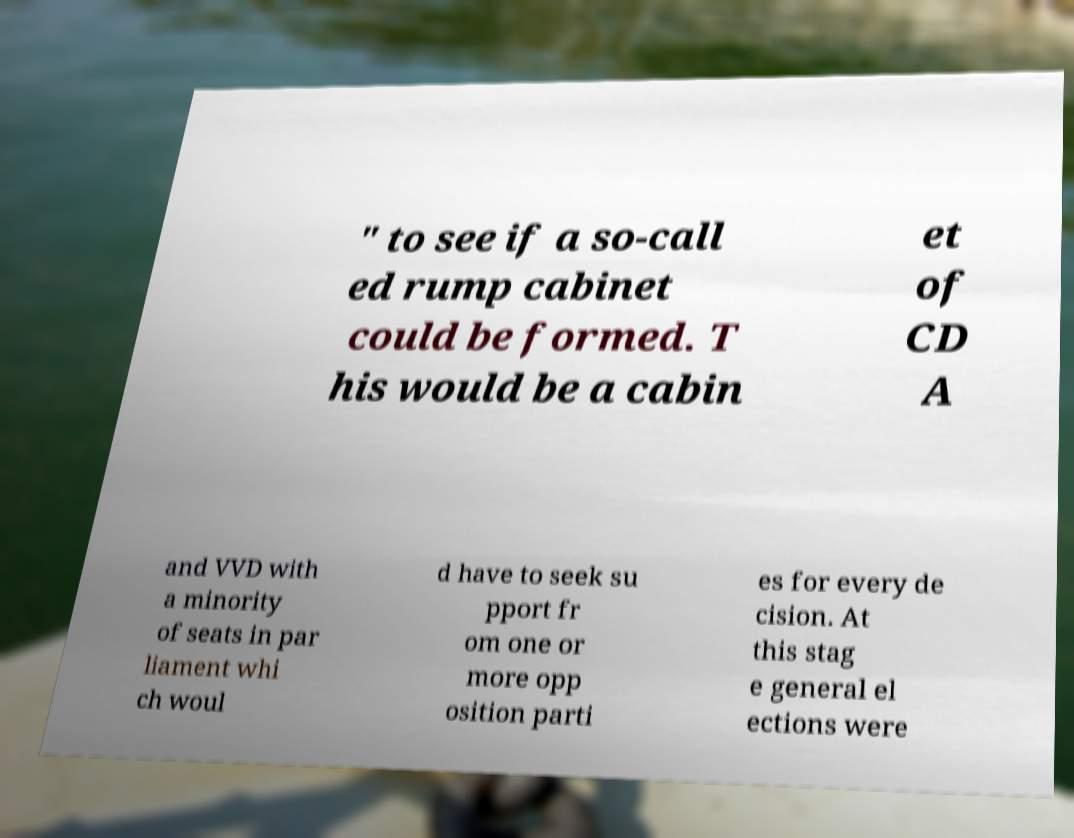There's text embedded in this image that I need extracted. Can you transcribe it verbatim? " to see if a so-call ed rump cabinet could be formed. T his would be a cabin et of CD A and VVD with a minority of seats in par liament whi ch woul d have to seek su pport fr om one or more opp osition parti es for every de cision. At this stag e general el ections were 